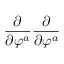<formula> <loc_0><loc_0><loc_500><loc_500>\frac { \partial } \partial \varphi ^ { a } } \frac { \partial } \partial \varphi ^ { a } }</formula> 